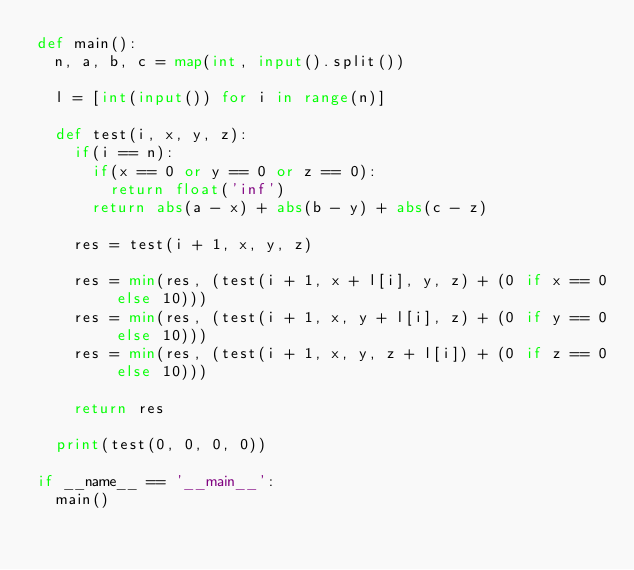Convert code to text. <code><loc_0><loc_0><loc_500><loc_500><_Python_>def main():
  n, a, b, c = map(int, input().split())

  l = [int(input()) for i in range(n)]

  def test(i, x, y, z):
    if(i == n):
      if(x == 0 or y == 0 or z == 0):
        return float('inf')
      return abs(a - x) + abs(b - y) + abs(c - z)

    res = test(i + 1, x, y, z)

    res = min(res, (test(i + 1, x + l[i], y, z) + (0 if x == 0 else 10))) 
    res = min(res, (test(i + 1, x, y + l[i], z) + (0 if y == 0 else 10))) 
    res = min(res, (test(i + 1, x, y, z + l[i]) + (0 if z == 0 else 10))) 

    return res

  print(test(0, 0, 0, 0))

if __name__ == '__main__':
  main()
</code> 